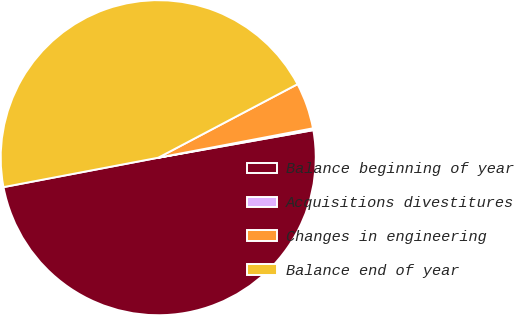Convert chart to OTSL. <chart><loc_0><loc_0><loc_500><loc_500><pie_chart><fcel>Balance beginning of year<fcel>Acquisitions divestitures<fcel>Changes in engineering<fcel>Balance end of year<nl><fcel>49.81%<fcel>0.19%<fcel>4.74%<fcel>45.26%<nl></chart> 